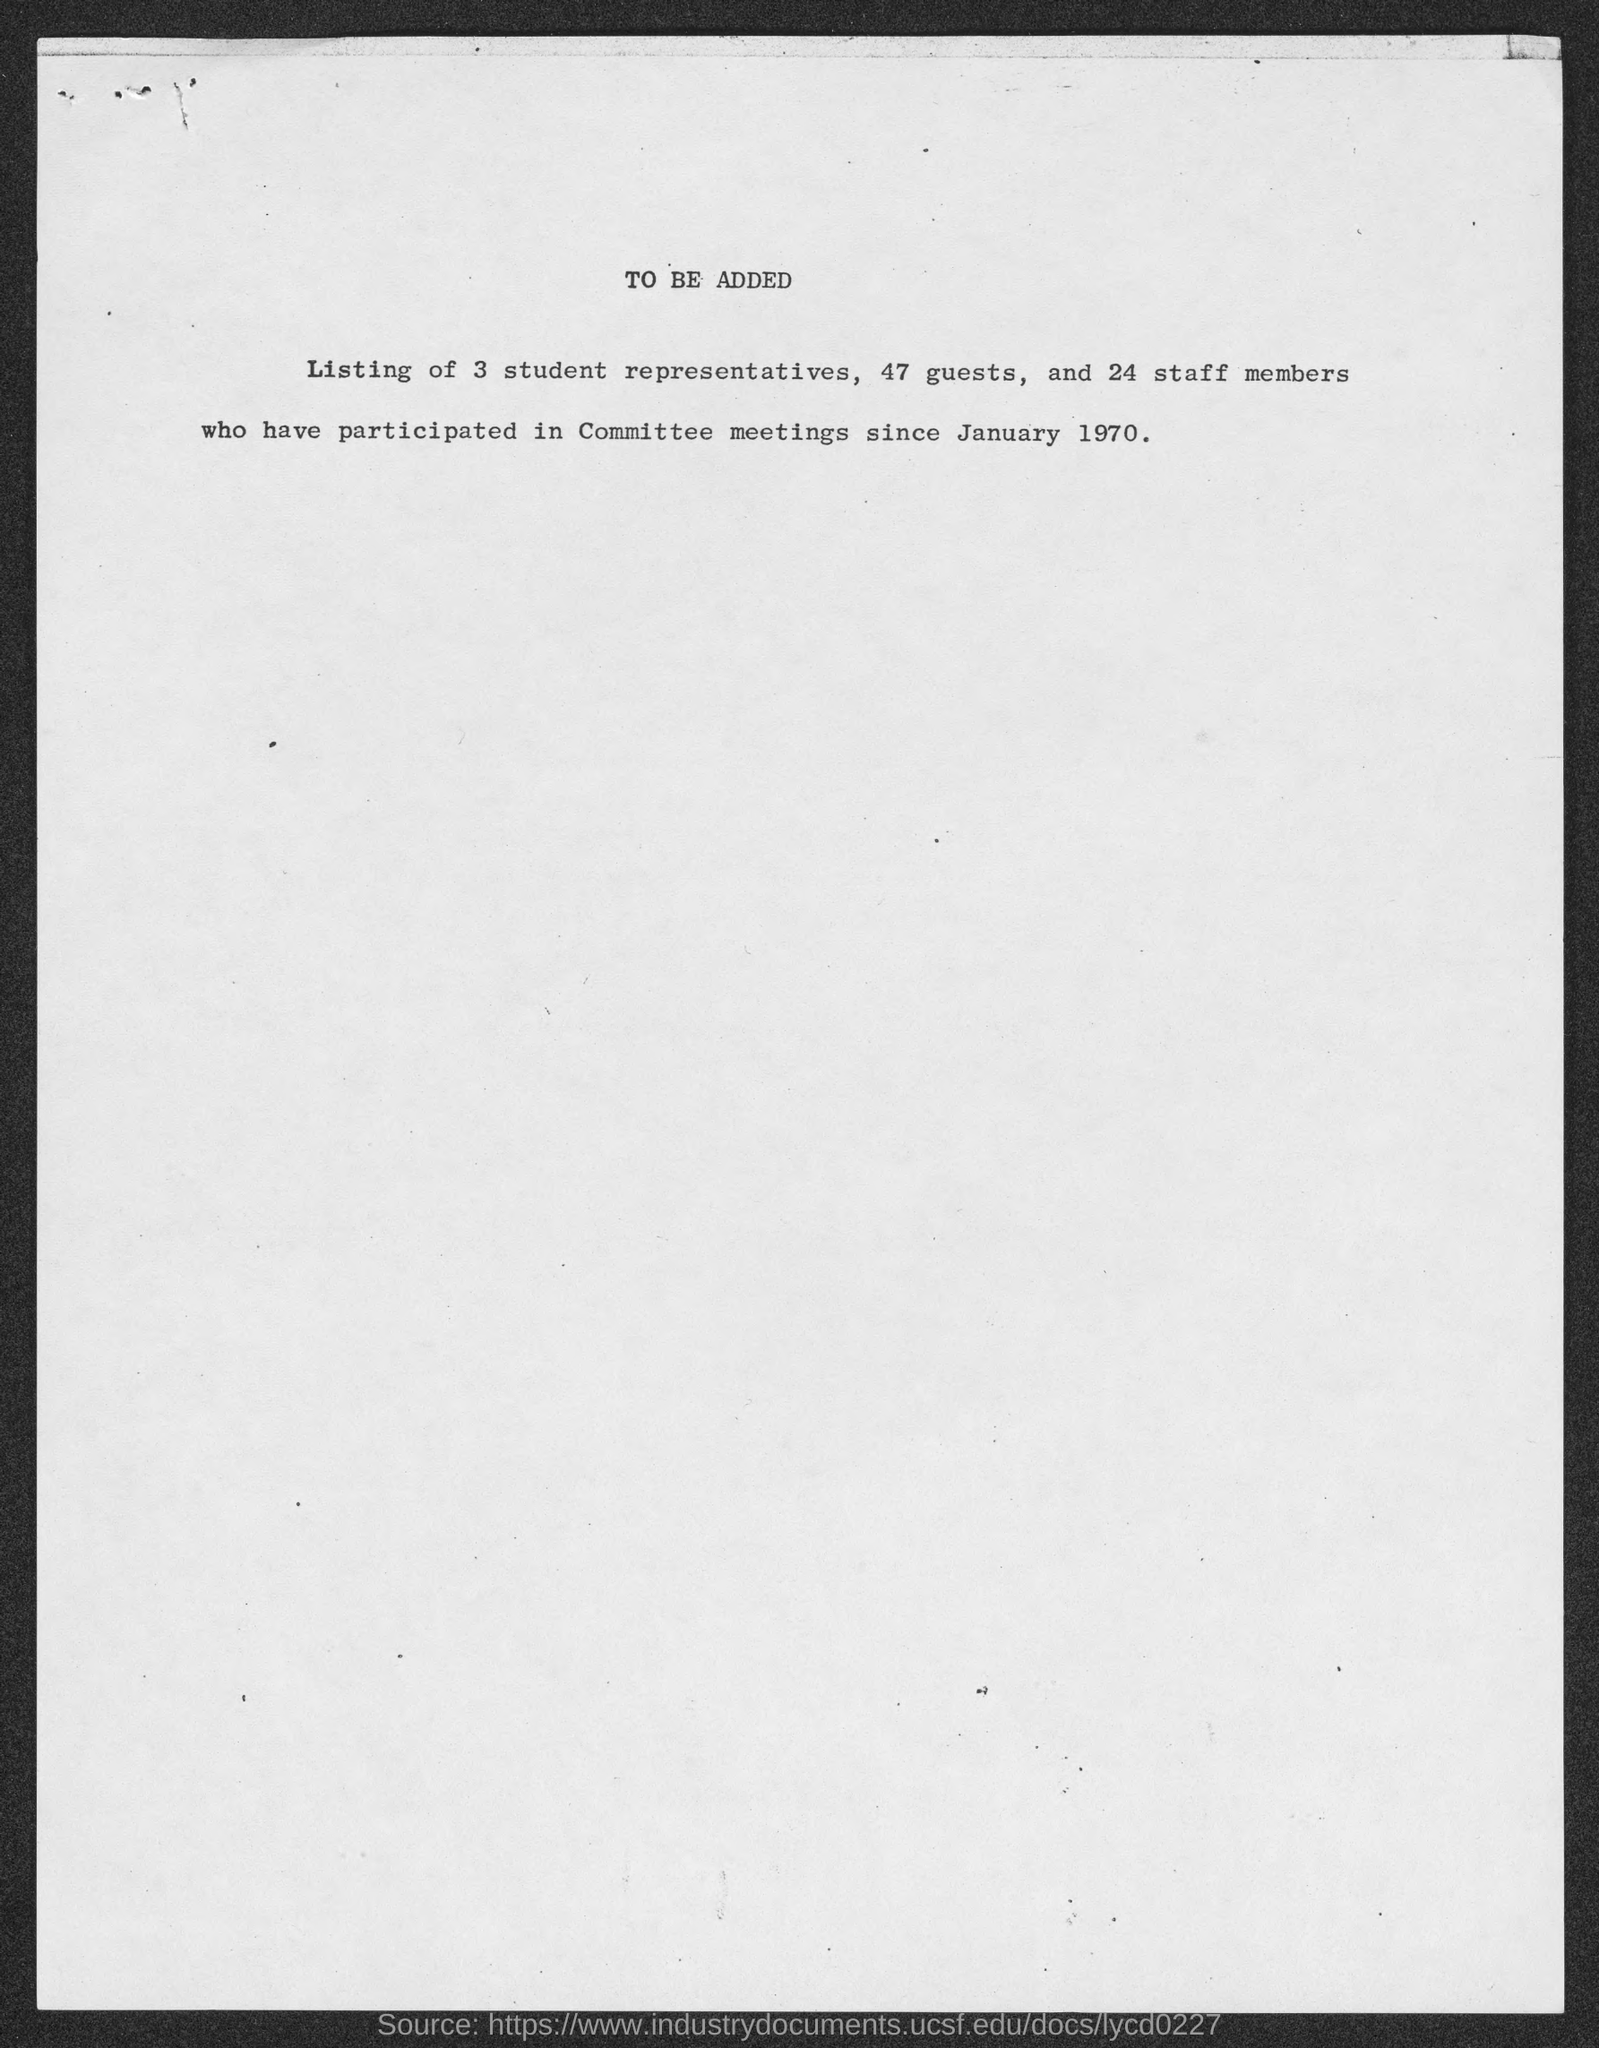What is the date mentioned in the document?
Your answer should be very brief. January 1970. How many guests have participated?
Offer a very short reply. 47. How many Staff members have participated?
Offer a very short reply. 24. 